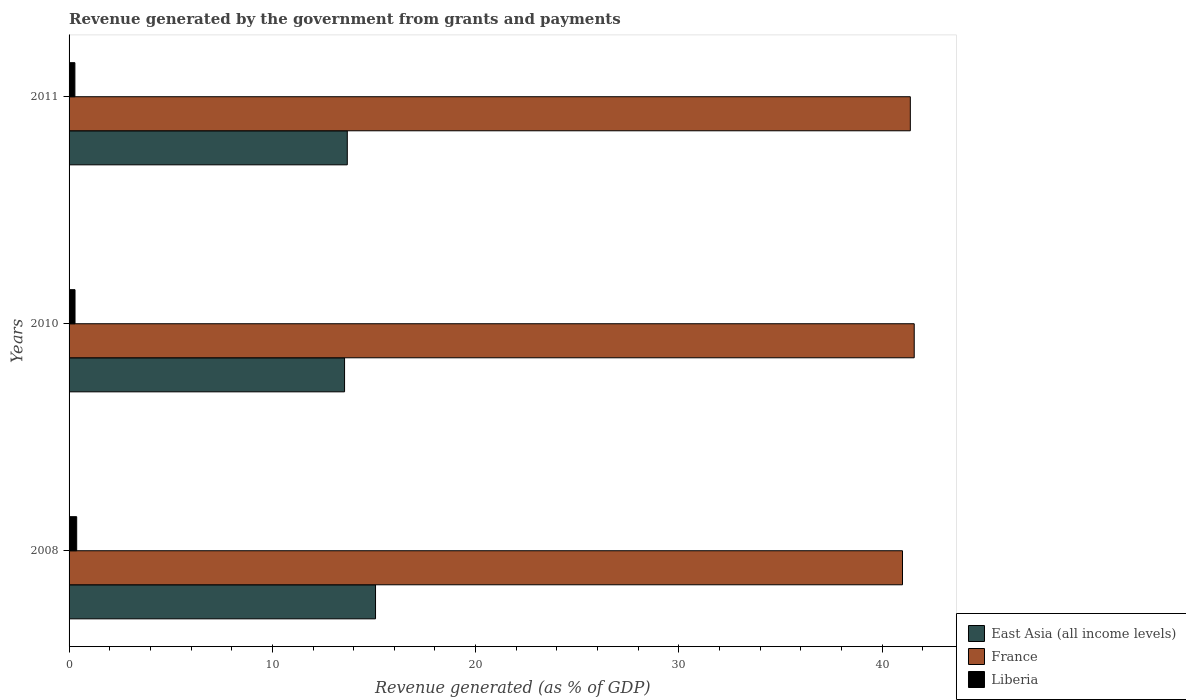Are the number of bars per tick equal to the number of legend labels?
Keep it short and to the point. Yes. Are the number of bars on each tick of the Y-axis equal?
Offer a terse response. Yes. How many bars are there on the 1st tick from the top?
Give a very brief answer. 3. How many bars are there on the 3rd tick from the bottom?
Your answer should be very brief. 3. In how many cases, is the number of bars for a given year not equal to the number of legend labels?
Provide a short and direct response. 0. What is the revenue generated by the government in East Asia (all income levels) in 2008?
Offer a terse response. 15.07. Across all years, what is the maximum revenue generated by the government in East Asia (all income levels)?
Your answer should be very brief. 15.07. Across all years, what is the minimum revenue generated by the government in Liberia?
Provide a short and direct response. 0.29. In which year was the revenue generated by the government in Liberia maximum?
Your answer should be very brief. 2008. In which year was the revenue generated by the government in France minimum?
Your response must be concise. 2008. What is the total revenue generated by the government in France in the graph?
Keep it short and to the point. 123.96. What is the difference between the revenue generated by the government in France in 2008 and that in 2010?
Give a very brief answer. -0.58. What is the difference between the revenue generated by the government in East Asia (all income levels) in 2010 and the revenue generated by the government in France in 2011?
Your answer should be compact. -27.83. What is the average revenue generated by the government in Liberia per year?
Make the answer very short. 0.32. In the year 2011, what is the difference between the revenue generated by the government in Liberia and revenue generated by the government in East Asia (all income levels)?
Make the answer very short. -13.4. What is the ratio of the revenue generated by the government in Liberia in 2008 to that in 2010?
Make the answer very short. 1.28. Is the revenue generated by the government in France in 2008 less than that in 2010?
Ensure brevity in your answer.  Yes. What is the difference between the highest and the second highest revenue generated by the government in Liberia?
Give a very brief answer. 0.08. What is the difference between the highest and the lowest revenue generated by the government in East Asia (all income levels)?
Provide a succinct answer. 1.52. What does the 3rd bar from the top in 2008 represents?
Your response must be concise. East Asia (all income levels). How many bars are there?
Provide a short and direct response. 9. Are all the bars in the graph horizontal?
Offer a terse response. Yes. What is the difference between two consecutive major ticks on the X-axis?
Give a very brief answer. 10. Are the values on the major ticks of X-axis written in scientific E-notation?
Your answer should be compact. No. Where does the legend appear in the graph?
Offer a very short reply. Bottom right. What is the title of the graph?
Provide a short and direct response. Revenue generated by the government from grants and payments. Does "Pakistan" appear as one of the legend labels in the graph?
Give a very brief answer. No. What is the label or title of the X-axis?
Offer a terse response. Revenue generated (as % of GDP). What is the Revenue generated (as % of GDP) in East Asia (all income levels) in 2008?
Your response must be concise. 15.07. What is the Revenue generated (as % of GDP) in France in 2008?
Offer a terse response. 41. What is the Revenue generated (as % of GDP) of Liberia in 2008?
Your answer should be very brief. 0.37. What is the Revenue generated (as % of GDP) of East Asia (all income levels) in 2010?
Provide a succinct answer. 13.55. What is the Revenue generated (as % of GDP) of France in 2010?
Your answer should be very brief. 41.57. What is the Revenue generated (as % of GDP) of Liberia in 2010?
Ensure brevity in your answer.  0.29. What is the Revenue generated (as % of GDP) in East Asia (all income levels) in 2011?
Keep it short and to the point. 13.69. What is the Revenue generated (as % of GDP) of France in 2011?
Offer a terse response. 41.38. What is the Revenue generated (as % of GDP) of Liberia in 2011?
Offer a very short reply. 0.29. Across all years, what is the maximum Revenue generated (as % of GDP) of East Asia (all income levels)?
Keep it short and to the point. 15.07. Across all years, what is the maximum Revenue generated (as % of GDP) in France?
Provide a short and direct response. 41.57. Across all years, what is the maximum Revenue generated (as % of GDP) of Liberia?
Offer a very short reply. 0.37. Across all years, what is the minimum Revenue generated (as % of GDP) in East Asia (all income levels)?
Keep it short and to the point. 13.55. Across all years, what is the minimum Revenue generated (as % of GDP) of France?
Your response must be concise. 41. Across all years, what is the minimum Revenue generated (as % of GDP) in Liberia?
Your answer should be compact. 0.29. What is the total Revenue generated (as % of GDP) in East Asia (all income levels) in the graph?
Offer a terse response. 42.31. What is the total Revenue generated (as % of GDP) in France in the graph?
Provide a short and direct response. 123.96. What is the total Revenue generated (as % of GDP) in Liberia in the graph?
Ensure brevity in your answer.  0.95. What is the difference between the Revenue generated (as % of GDP) in East Asia (all income levels) in 2008 and that in 2010?
Provide a short and direct response. 1.52. What is the difference between the Revenue generated (as % of GDP) of France in 2008 and that in 2010?
Provide a succinct answer. -0.58. What is the difference between the Revenue generated (as % of GDP) in Liberia in 2008 and that in 2010?
Give a very brief answer. 0.08. What is the difference between the Revenue generated (as % of GDP) of East Asia (all income levels) in 2008 and that in 2011?
Offer a terse response. 1.39. What is the difference between the Revenue generated (as % of GDP) in France in 2008 and that in 2011?
Keep it short and to the point. -0.38. What is the difference between the Revenue generated (as % of GDP) of Liberia in 2008 and that in 2011?
Your answer should be compact. 0.09. What is the difference between the Revenue generated (as % of GDP) in East Asia (all income levels) in 2010 and that in 2011?
Your answer should be very brief. -0.13. What is the difference between the Revenue generated (as % of GDP) of France in 2010 and that in 2011?
Your response must be concise. 0.19. What is the difference between the Revenue generated (as % of GDP) in Liberia in 2010 and that in 2011?
Provide a succinct answer. 0.01. What is the difference between the Revenue generated (as % of GDP) in East Asia (all income levels) in 2008 and the Revenue generated (as % of GDP) in France in 2010?
Your answer should be very brief. -26.5. What is the difference between the Revenue generated (as % of GDP) in East Asia (all income levels) in 2008 and the Revenue generated (as % of GDP) in Liberia in 2010?
Offer a very short reply. 14.78. What is the difference between the Revenue generated (as % of GDP) of France in 2008 and the Revenue generated (as % of GDP) of Liberia in 2010?
Offer a very short reply. 40.71. What is the difference between the Revenue generated (as % of GDP) in East Asia (all income levels) in 2008 and the Revenue generated (as % of GDP) in France in 2011?
Ensure brevity in your answer.  -26.31. What is the difference between the Revenue generated (as % of GDP) in East Asia (all income levels) in 2008 and the Revenue generated (as % of GDP) in Liberia in 2011?
Make the answer very short. 14.79. What is the difference between the Revenue generated (as % of GDP) in France in 2008 and the Revenue generated (as % of GDP) in Liberia in 2011?
Make the answer very short. 40.71. What is the difference between the Revenue generated (as % of GDP) of East Asia (all income levels) in 2010 and the Revenue generated (as % of GDP) of France in 2011?
Your answer should be very brief. -27.83. What is the difference between the Revenue generated (as % of GDP) of East Asia (all income levels) in 2010 and the Revenue generated (as % of GDP) of Liberia in 2011?
Your answer should be very brief. 13.27. What is the difference between the Revenue generated (as % of GDP) in France in 2010 and the Revenue generated (as % of GDP) in Liberia in 2011?
Your answer should be compact. 41.29. What is the average Revenue generated (as % of GDP) in East Asia (all income levels) per year?
Offer a terse response. 14.1. What is the average Revenue generated (as % of GDP) in France per year?
Ensure brevity in your answer.  41.32. What is the average Revenue generated (as % of GDP) in Liberia per year?
Offer a terse response. 0.32. In the year 2008, what is the difference between the Revenue generated (as % of GDP) of East Asia (all income levels) and Revenue generated (as % of GDP) of France?
Make the answer very short. -25.92. In the year 2008, what is the difference between the Revenue generated (as % of GDP) of East Asia (all income levels) and Revenue generated (as % of GDP) of Liberia?
Give a very brief answer. 14.7. In the year 2008, what is the difference between the Revenue generated (as % of GDP) in France and Revenue generated (as % of GDP) in Liberia?
Your response must be concise. 40.62. In the year 2010, what is the difference between the Revenue generated (as % of GDP) of East Asia (all income levels) and Revenue generated (as % of GDP) of France?
Make the answer very short. -28.02. In the year 2010, what is the difference between the Revenue generated (as % of GDP) of East Asia (all income levels) and Revenue generated (as % of GDP) of Liberia?
Offer a terse response. 13.26. In the year 2010, what is the difference between the Revenue generated (as % of GDP) in France and Revenue generated (as % of GDP) in Liberia?
Offer a very short reply. 41.28. In the year 2011, what is the difference between the Revenue generated (as % of GDP) of East Asia (all income levels) and Revenue generated (as % of GDP) of France?
Provide a succinct answer. -27.7. In the year 2011, what is the difference between the Revenue generated (as % of GDP) in East Asia (all income levels) and Revenue generated (as % of GDP) in Liberia?
Give a very brief answer. 13.4. In the year 2011, what is the difference between the Revenue generated (as % of GDP) in France and Revenue generated (as % of GDP) in Liberia?
Ensure brevity in your answer.  41.1. What is the ratio of the Revenue generated (as % of GDP) in East Asia (all income levels) in 2008 to that in 2010?
Make the answer very short. 1.11. What is the ratio of the Revenue generated (as % of GDP) of France in 2008 to that in 2010?
Ensure brevity in your answer.  0.99. What is the ratio of the Revenue generated (as % of GDP) in Liberia in 2008 to that in 2010?
Your answer should be very brief. 1.28. What is the ratio of the Revenue generated (as % of GDP) of East Asia (all income levels) in 2008 to that in 2011?
Your answer should be very brief. 1.1. What is the ratio of the Revenue generated (as % of GDP) of Liberia in 2008 to that in 2011?
Ensure brevity in your answer.  1.31. What is the ratio of the Revenue generated (as % of GDP) in East Asia (all income levels) in 2010 to that in 2011?
Give a very brief answer. 0.99. What is the ratio of the Revenue generated (as % of GDP) of Liberia in 2010 to that in 2011?
Make the answer very short. 1.02. What is the difference between the highest and the second highest Revenue generated (as % of GDP) of East Asia (all income levels)?
Offer a terse response. 1.39. What is the difference between the highest and the second highest Revenue generated (as % of GDP) in France?
Give a very brief answer. 0.19. What is the difference between the highest and the second highest Revenue generated (as % of GDP) of Liberia?
Ensure brevity in your answer.  0.08. What is the difference between the highest and the lowest Revenue generated (as % of GDP) in East Asia (all income levels)?
Keep it short and to the point. 1.52. What is the difference between the highest and the lowest Revenue generated (as % of GDP) of France?
Provide a succinct answer. 0.58. What is the difference between the highest and the lowest Revenue generated (as % of GDP) in Liberia?
Keep it short and to the point. 0.09. 